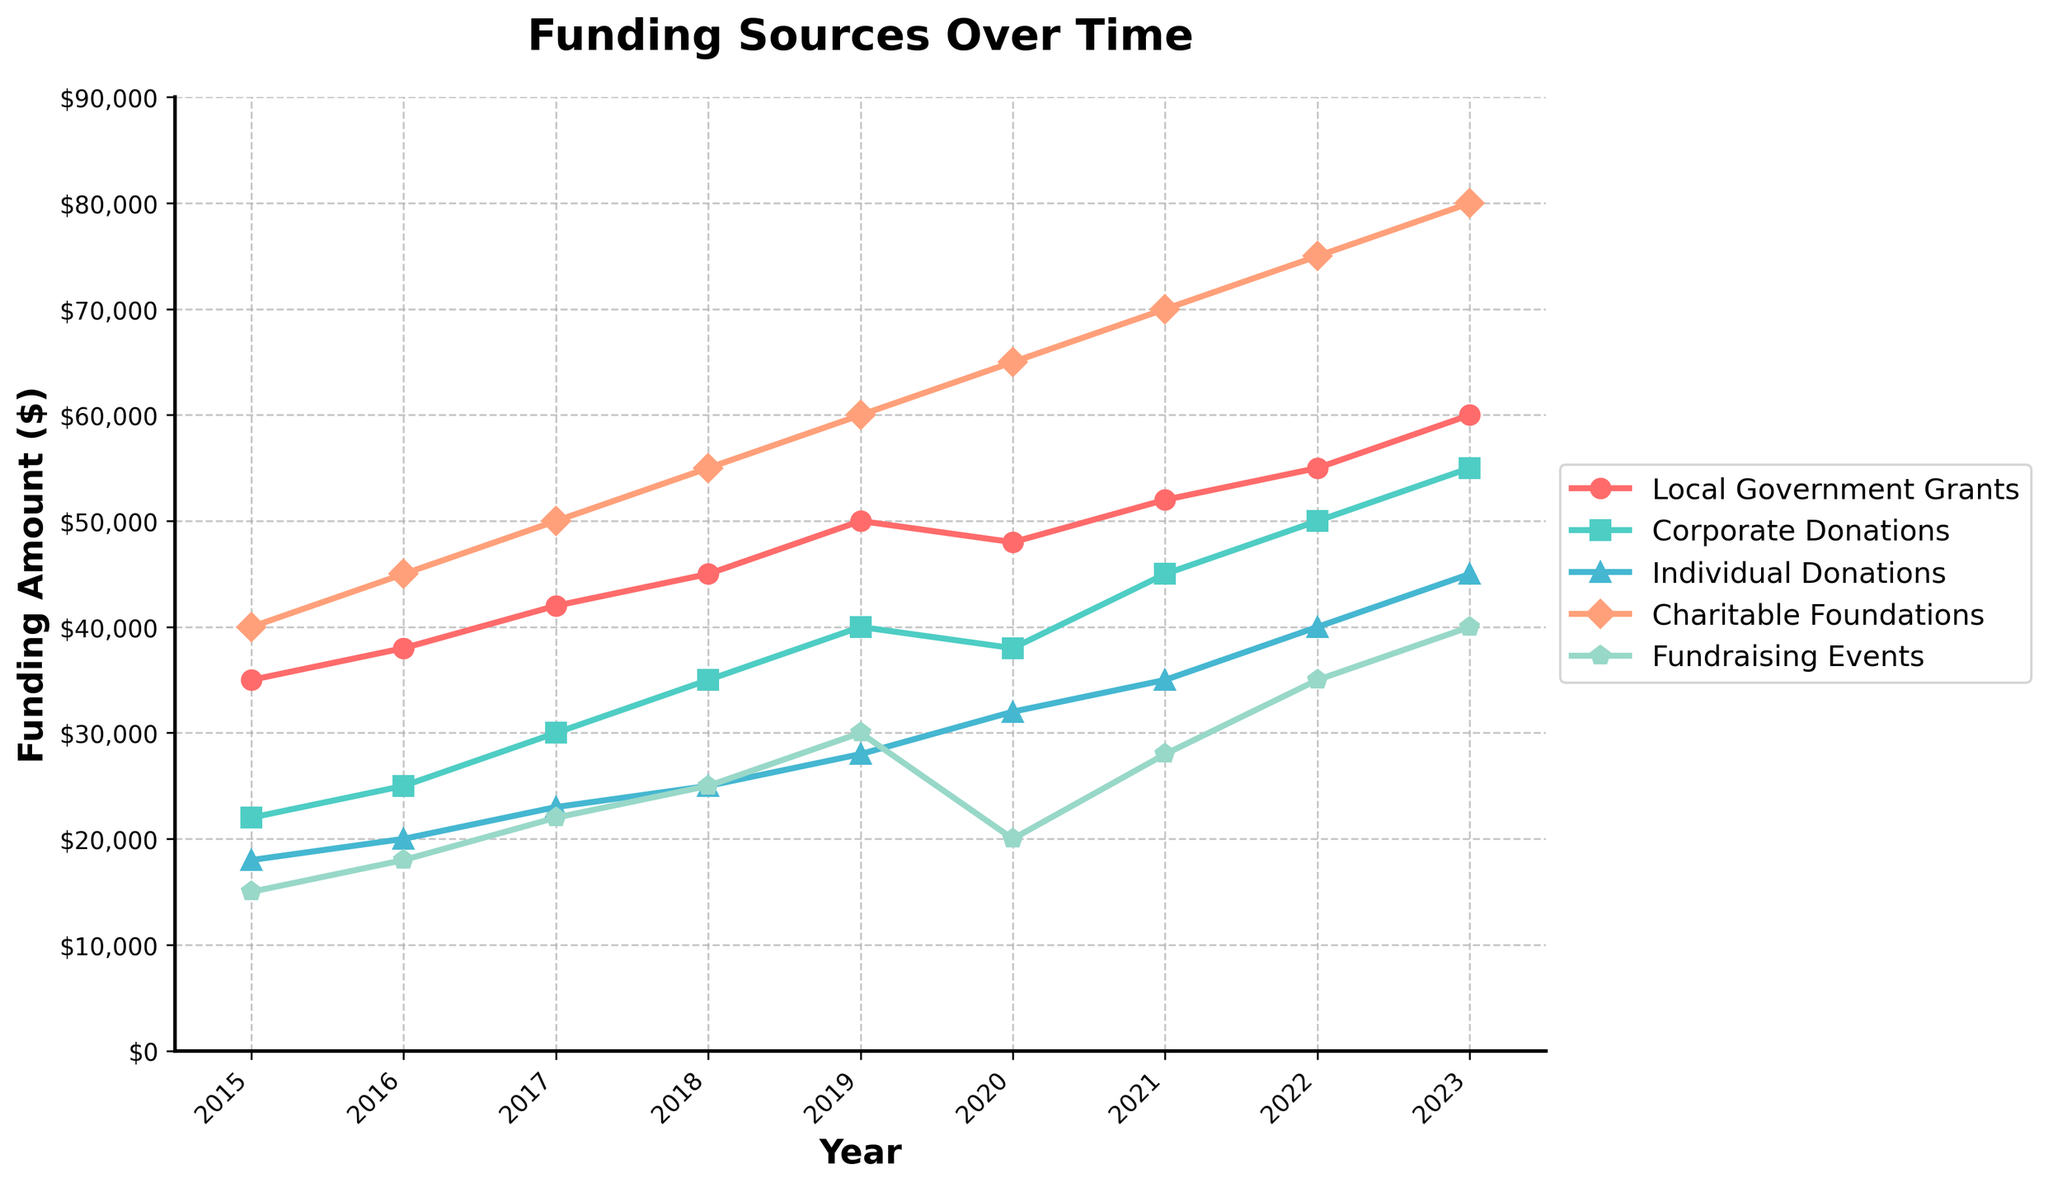What's the trend of funding from Local Government Grants from 2015 to 2023? The Local Government Grants funding steadily increases over the years from $35,000 in 2015 to $60,000 in 2023.
Answer: Steady increase Which year had the highest total funding from all sources combined? Summing up all funding sources for each year, 2023 has the highest total funding. For 2023: $60,000 (Local Govt Grants) + $55,000 (Corporate Donations) + $45,000 (Individual Donations) + $80,000 (Charitable Foundations) + $40,000 (Fundraising Events) = $280,000.
Answer: 2023 How does the funding from Corporate Donations in 2017 compare to 2022? In 2017, Corporate Donations were $30,000, and in 2022, they were $50,000. The funding more than doubled over these years.
Answer: More than doubled By how much did Individual Donations increase from 2015 to 2023? Individual Donations in 2015 were $18,000 and in 2023 were $45,000. The increase is calculated by $45,000 - $18,000 = $27,000.
Answer: $27,000 Which funding source had the most consistent increase over the time period? By examining the slopes of the lines, Charitable Foundations consistently increased every year. It started at $40,000 in 2015 and reached $80,000 in 2023.
Answer: Charitable Foundations What is the average annual funding received from Fundraising Events over the period 2015-2023? Add up the yearly funding amounts from Fundraising Events: $15,000 + $18,000 + $22,000 + $25,000 + $30,000 + $20,000 + $28,000 + $35,000 + $40,000 = $233,000. There are 9 years, so the average is $233,000 / 9 ≈ $25,889.
Answer: $25,889 In which year did Charitable Foundations' funding surpass $50,000? Looking at the Charitable Foundations' funding line, it surpassed $50,000 in 2018 when it reached $55,000.
Answer: 2018 Which two years saw the largest increase in Corporate Donations, and what was the amount of increase? The largest increases are from 2018 to 2019 and from 2022 to 2023, both by $50,000 - $35,000 = $15,000.
Answer: 2018-2019 and 2022-2023, $15,000 How did Fundraising Events' funding trend in 2020 and 2021? Fundraising Events' funding decreased from $30,000 in 2019 to $20,000 in 2020, then increased to $28,000 in 2021.
Answer: Decrease then increase 